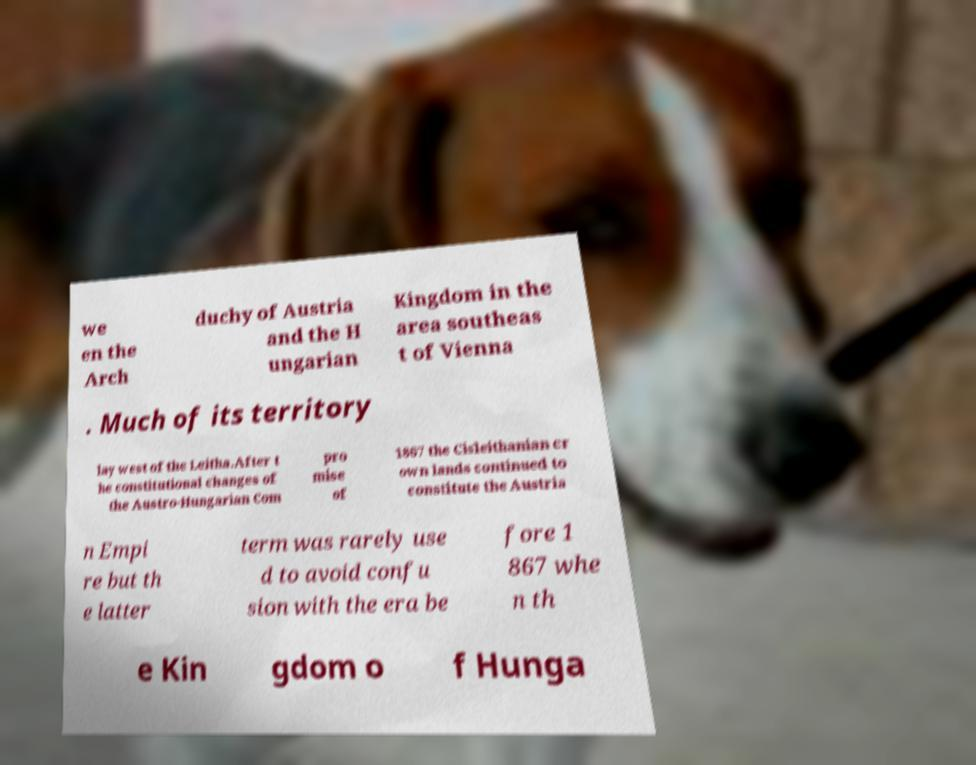Could you extract and type out the text from this image? we en the Arch duchy of Austria and the H ungarian Kingdom in the area southeas t of Vienna . Much of its territory lay west of the Leitha.After t he constitutional changes of the Austro-Hungarian Com pro mise of 1867 the Cisleithanian cr own lands continued to constitute the Austria n Empi re but th e latter term was rarely use d to avoid confu sion with the era be fore 1 867 whe n th e Kin gdom o f Hunga 